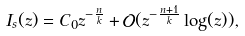Convert formula to latex. <formula><loc_0><loc_0><loc_500><loc_500>I _ { s } ( z ) = C _ { 0 } z ^ { - \frac { n } { k } } + \mathcal { O } ( z ^ { - \frac { n + 1 } { k } } \log ( z ) ) ,</formula> 